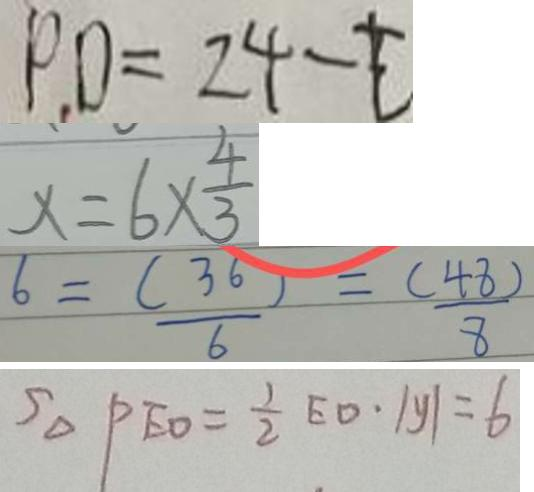Convert formula to latex. <formula><loc_0><loc_0><loc_500><loc_500>P D = 2 4 - t 
 x = 6 \times \frac { 4 } { 3 } 
 6 = \frac { ( 3 6 ) } { 6 } = \frac { ( 4 8 ) } { 8 } 
 S _ { \Delta } P E O = \frac { 1 } { 2 } E D \cdot \vert y \vert = 6</formula> 